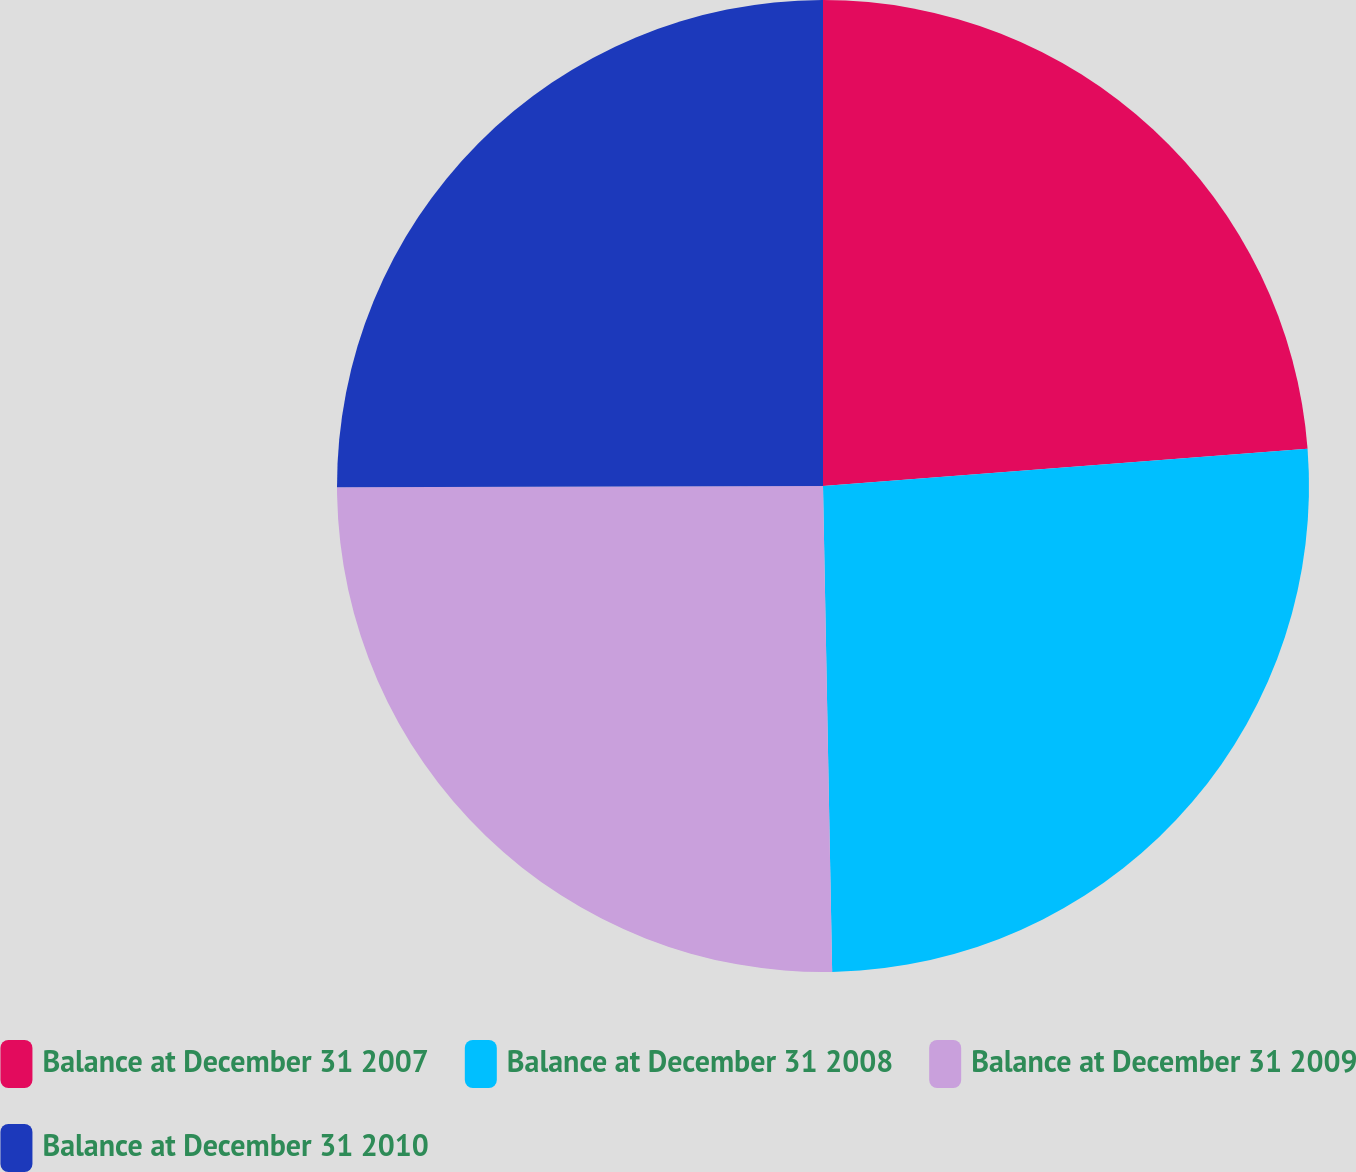<chart> <loc_0><loc_0><loc_500><loc_500><pie_chart><fcel>Balance at December 31 2007<fcel>Balance at December 31 2008<fcel>Balance at December 31 2009<fcel>Balance at December 31 2010<nl><fcel>23.78%<fcel>25.92%<fcel>25.26%<fcel>25.04%<nl></chart> 